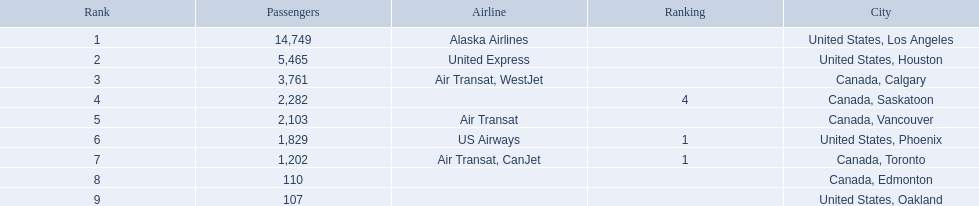Where are the destinations of the airport? United States, Los Angeles, United States, Houston, Canada, Calgary, Canada, Saskatoon, Canada, Vancouver, United States, Phoenix, Canada, Toronto, Canada, Edmonton, United States, Oakland. What is the number of passengers to phoenix? 1,829. 